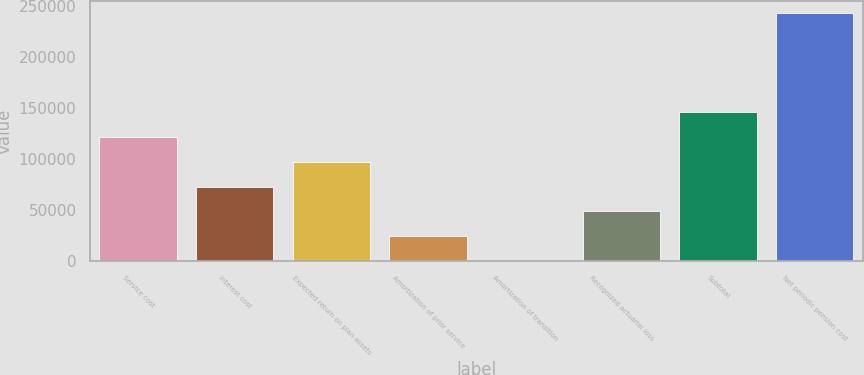<chart> <loc_0><loc_0><loc_500><loc_500><bar_chart><fcel>Service cost<fcel>Interest cost<fcel>Expected return on plan assets<fcel>Amortization of prior service<fcel>Amortization of transition<fcel>Recognized actuarial loss<fcel>Subtotal<fcel>Net periodic pension cost<nl><fcel>121606<fcel>72971.1<fcel>97288.8<fcel>24335.7<fcel>18<fcel>48653.4<fcel>145924<fcel>243195<nl></chart> 